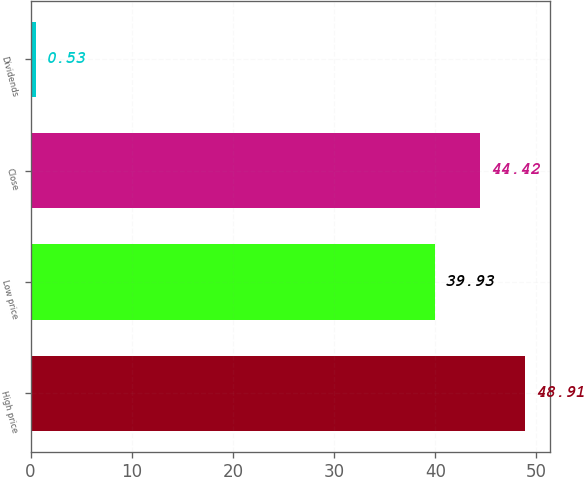Convert chart. <chart><loc_0><loc_0><loc_500><loc_500><bar_chart><fcel>High price<fcel>Low price<fcel>Close<fcel>Dividends<nl><fcel>48.91<fcel>39.93<fcel>44.42<fcel>0.53<nl></chart> 